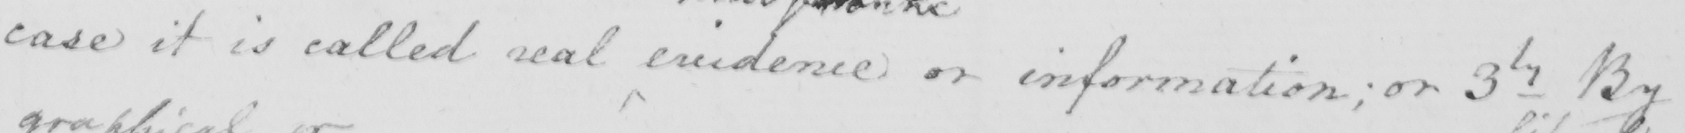Can you tell me what this handwritten text says? case it is called real evidence or information ; or 3ly By 